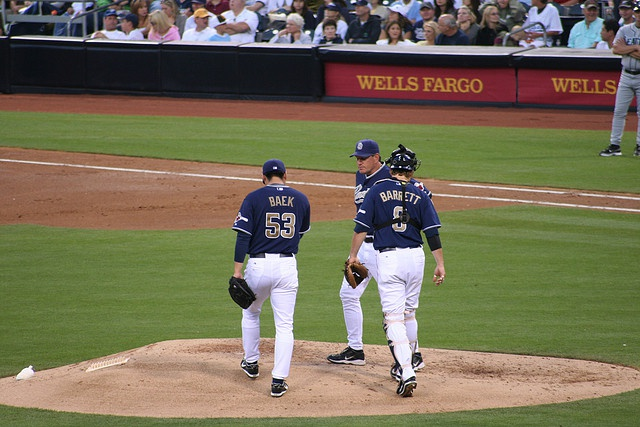Describe the objects in this image and their specific colors. I can see people in black, gray, lavender, and maroon tones, people in black, lavender, navy, and darkgray tones, people in black, lavender, navy, and darkgray tones, people in black, lavender, and navy tones, and people in black, gray, and darkgray tones in this image. 